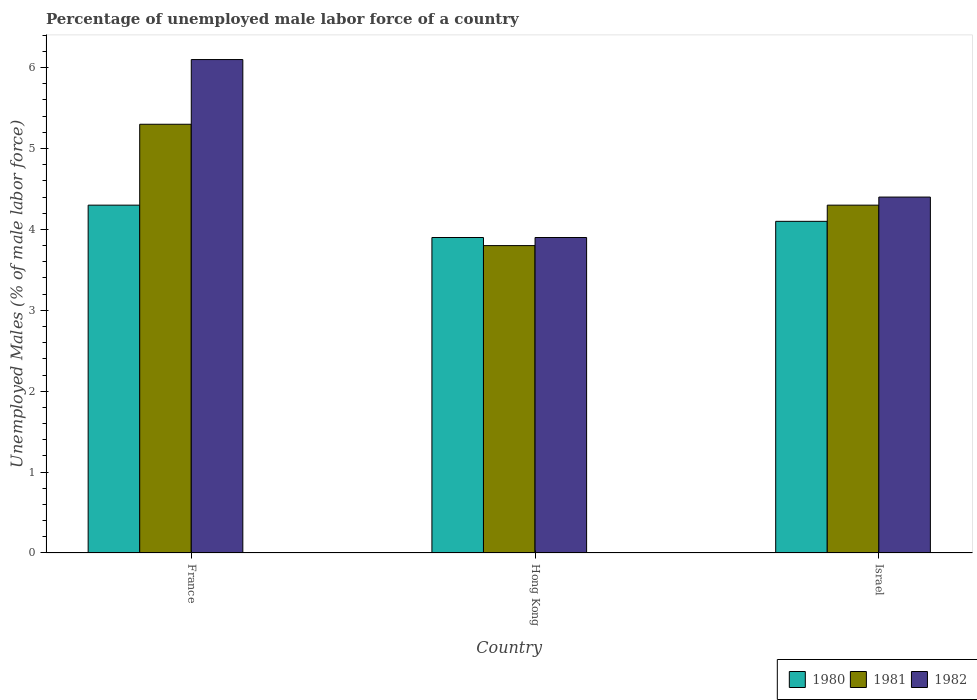How many different coloured bars are there?
Make the answer very short. 3. Are the number of bars per tick equal to the number of legend labels?
Your answer should be compact. Yes. Are the number of bars on each tick of the X-axis equal?
Ensure brevity in your answer.  Yes. How many bars are there on the 3rd tick from the left?
Your answer should be very brief. 3. How many bars are there on the 3rd tick from the right?
Provide a succinct answer. 3. In how many cases, is the number of bars for a given country not equal to the number of legend labels?
Offer a terse response. 0. What is the percentage of unemployed male labor force in 1980 in France?
Your answer should be compact. 4.3. Across all countries, what is the maximum percentage of unemployed male labor force in 1980?
Offer a very short reply. 4.3. Across all countries, what is the minimum percentage of unemployed male labor force in 1981?
Provide a succinct answer. 3.8. In which country was the percentage of unemployed male labor force in 1981 minimum?
Your answer should be very brief. Hong Kong. What is the total percentage of unemployed male labor force in 1982 in the graph?
Provide a short and direct response. 14.4. What is the difference between the percentage of unemployed male labor force in 1982 in France and that in Israel?
Your answer should be very brief. 1.7. What is the difference between the percentage of unemployed male labor force in 1982 in France and the percentage of unemployed male labor force in 1980 in Israel?
Provide a short and direct response. 2. What is the average percentage of unemployed male labor force in 1981 per country?
Your answer should be very brief. 4.47. What is the difference between the percentage of unemployed male labor force of/in 1981 and percentage of unemployed male labor force of/in 1982 in Israel?
Your answer should be very brief. -0.1. In how many countries, is the percentage of unemployed male labor force in 1981 greater than 0.6000000000000001 %?
Your response must be concise. 3. What is the ratio of the percentage of unemployed male labor force in 1980 in France to that in Israel?
Offer a very short reply. 1.05. Is the percentage of unemployed male labor force in 1982 in Hong Kong less than that in Israel?
Your answer should be compact. Yes. Is the difference between the percentage of unemployed male labor force in 1981 in Hong Kong and Israel greater than the difference between the percentage of unemployed male labor force in 1982 in Hong Kong and Israel?
Ensure brevity in your answer.  No. What is the difference between the highest and the second highest percentage of unemployed male labor force in 1980?
Your answer should be very brief. -0.4. What is the difference between the highest and the lowest percentage of unemployed male labor force in 1980?
Provide a short and direct response. 0.4. In how many countries, is the percentage of unemployed male labor force in 1980 greater than the average percentage of unemployed male labor force in 1980 taken over all countries?
Ensure brevity in your answer.  1. What does the 2nd bar from the left in Israel represents?
Give a very brief answer. 1981. What does the 3rd bar from the right in Hong Kong represents?
Offer a terse response. 1980. Is it the case that in every country, the sum of the percentage of unemployed male labor force in 1982 and percentage of unemployed male labor force in 1980 is greater than the percentage of unemployed male labor force in 1981?
Your answer should be very brief. Yes. How many bars are there?
Your answer should be very brief. 9. Are all the bars in the graph horizontal?
Offer a terse response. No. Are the values on the major ticks of Y-axis written in scientific E-notation?
Your answer should be compact. No. Does the graph contain any zero values?
Offer a terse response. No. Where does the legend appear in the graph?
Keep it short and to the point. Bottom right. How many legend labels are there?
Your response must be concise. 3. How are the legend labels stacked?
Ensure brevity in your answer.  Horizontal. What is the title of the graph?
Your answer should be very brief. Percentage of unemployed male labor force of a country. What is the label or title of the X-axis?
Your answer should be very brief. Country. What is the label or title of the Y-axis?
Provide a short and direct response. Unemployed Males (% of male labor force). What is the Unemployed Males (% of male labor force) in 1980 in France?
Make the answer very short. 4.3. What is the Unemployed Males (% of male labor force) in 1981 in France?
Give a very brief answer. 5.3. What is the Unemployed Males (% of male labor force) in 1982 in France?
Offer a terse response. 6.1. What is the Unemployed Males (% of male labor force) in 1980 in Hong Kong?
Ensure brevity in your answer.  3.9. What is the Unemployed Males (% of male labor force) of 1981 in Hong Kong?
Provide a succinct answer. 3.8. What is the Unemployed Males (% of male labor force) of 1982 in Hong Kong?
Ensure brevity in your answer.  3.9. What is the Unemployed Males (% of male labor force) of 1980 in Israel?
Your answer should be very brief. 4.1. What is the Unemployed Males (% of male labor force) in 1981 in Israel?
Make the answer very short. 4.3. What is the Unemployed Males (% of male labor force) in 1982 in Israel?
Your response must be concise. 4.4. Across all countries, what is the maximum Unemployed Males (% of male labor force) in 1980?
Your answer should be compact. 4.3. Across all countries, what is the maximum Unemployed Males (% of male labor force) of 1981?
Your response must be concise. 5.3. Across all countries, what is the maximum Unemployed Males (% of male labor force) of 1982?
Give a very brief answer. 6.1. Across all countries, what is the minimum Unemployed Males (% of male labor force) in 1980?
Give a very brief answer. 3.9. Across all countries, what is the minimum Unemployed Males (% of male labor force) of 1981?
Give a very brief answer. 3.8. Across all countries, what is the minimum Unemployed Males (% of male labor force) of 1982?
Provide a succinct answer. 3.9. What is the total Unemployed Males (% of male labor force) in 1980 in the graph?
Provide a succinct answer. 12.3. What is the total Unemployed Males (% of male labor force) of 1981 in the graph?
Offer a terse response. 13.4. What is the total Unemployed Males (% of male labor force) of 1982 in the graph?
Your answer should be very brief. 14.4. What is the difference between the Unemployed Males (% of male labor force) in 1980 in France and that in Hong Kong?
Keep it short and to the point. 0.4. What is the difference between the Unemployed Males (% of male labor force) of 1982 in France and that in Hong Kong?
Your answer should be very brief. 2.2. What is the difference between the Unemployed Males (% of male labor force) of 1980 in France and that in Israel?
Ensure brevity in your answer.  0.2. What is the difference between the Unemployed Males (% of male labor force) of 1980 in Hong Kong and that in Israel?
Your response must be concise. -0.2. What is the difference between the Unemployed Males (% of male labor force) of 1981 in Hong Kong and that in Israel?
Provide a short and direct response. -0.5. What is the difference between the Unemployed Males (% of male labor force) in 1982 in Hong Kong and that in Israel?
Provide a short and direct response. -0.5. What is the difference between the Unemployed Males (% of male labor force) of 1980 in France and the Unemployed Males (% of male labor force) of 1981 in Israel?
Your answer should be very brief. 0. What is the average Unemployed Males (% of male labor force) in 1981 per country?
Keep it short and to the point. 4.47. What is the average Unemployed Males (% of male labor force) of 1982 per country?
Your response must be concise. 4.8. What is the difference between the Unemployed Males (% of male labor force) of 1980 and Unemployed Males (% of male labor force) of 1981 in Hong Kong?
Provide a succinct answer. 0.1. What is the difference between the Unemployed Males (% of male labor force) in 1980 and Unemployed Males (% of male labor force) in 1982 in Hong Kong?
Your response must be concise. 0. What is the difference between the Unemployed Males (% of male labor force) in 1980 and Unemployed Males (% of male labor force) in 1981 in Israel?
Keep it short and to the point. -0.2. What is the difference between the Unemployed Males (% of male labor force) in 1980 and Unemployed Males (% of male labor force) in 1982 in Israel?
Make the answer very short. -0.3. What is the difference between the Unemployed Males (% of male labor force) of 1981 and Unemployed Males (% of male labor force) of 1982 in Israel?
Give a very brief answer. -0.1. What is the ratio of the Unemployed Males (% of male labor force) of 1980 in France to that in Hong Kong?
Make the answer very short. 1.1. What is the ratio of the Unemployed Males (% of male labor force) of 1981 in France to that in Hong Kong?
Provide a short and direct response. 1.39. What is the ratio of the Unemployed Males (% of male labor force) of 1982 in France to that in Hong Kong?
Make the answer very short. 1.56. What is the ratio of the Unemployed Males (% of male labor force) in 1980 in France to that in Israel?
Offer a terse response. 1.05. What is the ratio of the Unemployed Males (% of male labor force) of 1981 in France to that in Israel?
Your answer should be very brief. 1.23. What is the ratio of the Unemployed Males (% of male labor force) in 1982 in France to that in Israel?
Offer a terse response. 1.39. What is the ratio of the Unemployed Males (% of male labor force) of 1980 in Hong Kong to that in Israel?
Offer a very short reply. 0.95. What is the ratio of the Unemployed Males (% of male labor force) of 1981 in Hong Kong to that in Israel?
Make the answer very short. 0.88. What is the ratio of the Unemployed Males (% of male labor force) in 1982 in Hong Kong to that in Israel?
Offer a terse response. 0.89. What is the difference between the highest and the second highest Unemployed Males (% of male labor force) in 1980?
Keep it short and to the point. 0.2. What is the difference between the highest and the second highest Unemployed Males (% of male labor force) in 1982?
Your answer should be compact. 1.7. What is the difference between the highest and the lowest Unemployed Males (% of male labor force) in 1980?
Make the answer very short. 0.4. What is the difference between the highest and the lowest Unemployed Males (% of male labor force) of 1981?
Make the answer very short. 1.5. What is the difference between the highest and the lowest Unemployed Males (% of male labor force) in 1982?
Your response must be concise. 2.2. 